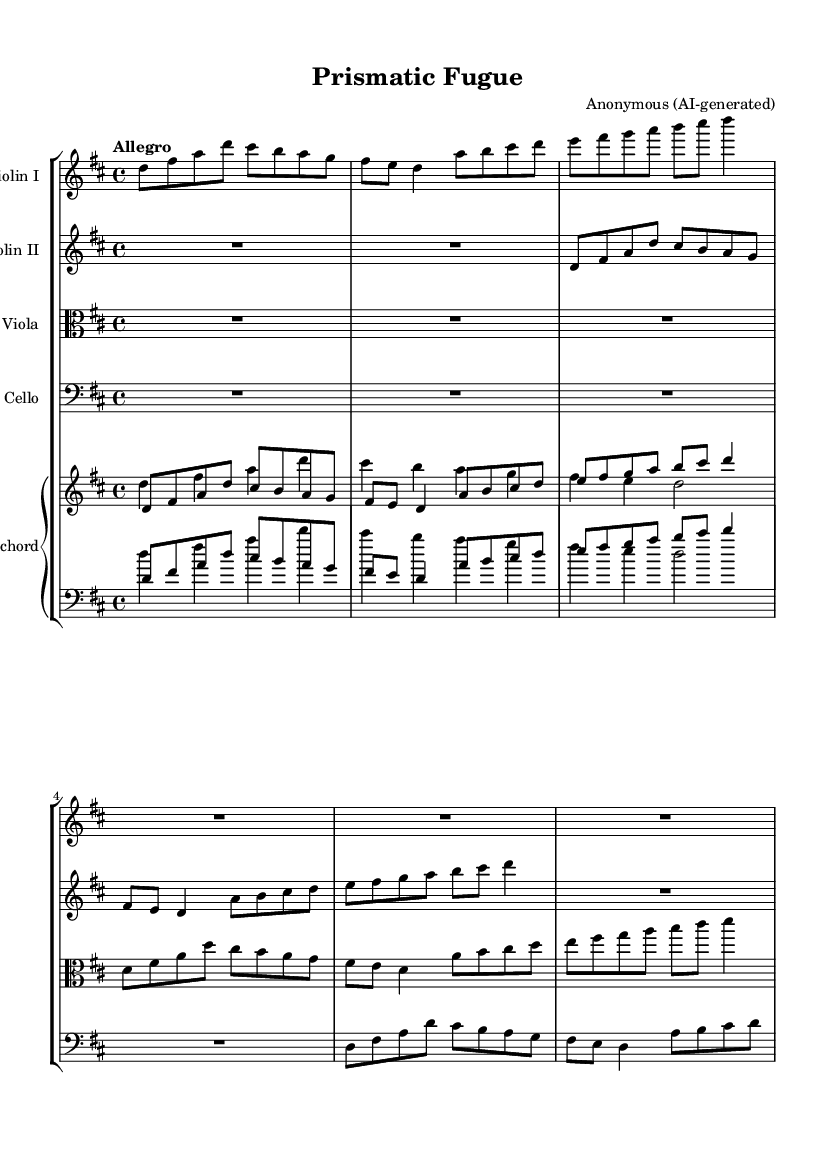What is the key signature of this music? The key signature is indicated at the beginning of the score after the clef sign. In this case, there are two sharps (F# and C#), which corresponds to the key signature of D major.
Answer: D major What is the time signature of this music? The time signature can be found right at the beginning of the score. Here, it is represented as a fraction with a '4' on the top and a '4' on the bottom, indicating that there are four beats in a measure, and each beat is a quarter note long.
Answer: 4/4 What is the tempo indication given in the sheet music? The tempo is stated at the beginning of the score following the time signature. It reads "Allegro," which indicates a fast and lively tempo.
Answer: Allegro How many measures are present in the score? By counting the number of vertical lines in the score that indicate the end of each measure in the main instrumental parts, we find that there are a total of eight measures visible in the parts provided.
Answer: 8 Which instruments are featured in this composition? Observing the score, each staff is labeled with the respective instrument name at the beginning. The instruments listed are Violin I, Violin II, Viola, Cello, and Harpsichord.
Answer: Violin I, Violin II, Viola, Cello, Harpsichord What is the compositional form of this piece? Analyzing the structure of the score, we can notice that it consists of interwoven melodies, typical of a fugue, where multiple voices enter successively, suggesting a complex counterpoint akin to Baroque style.
Answer: Fugue 